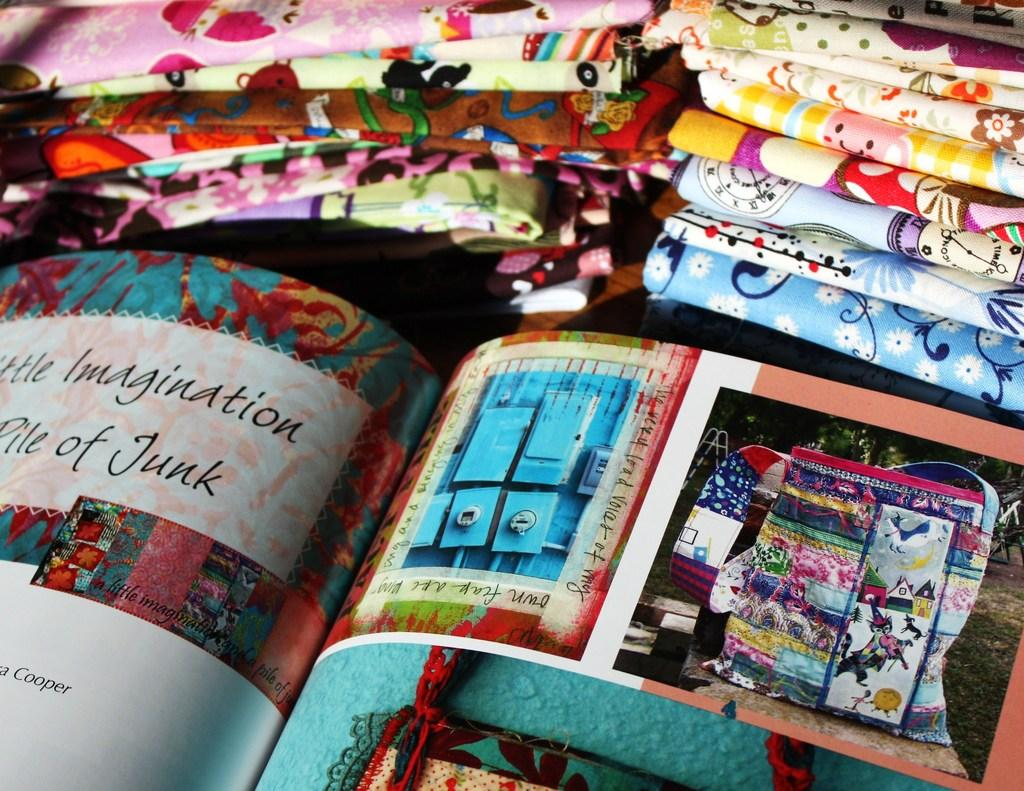<image>
Give a short and clear explanation of the subsequent image. A book opened to a page that discusses imagination and a pile of junk. 